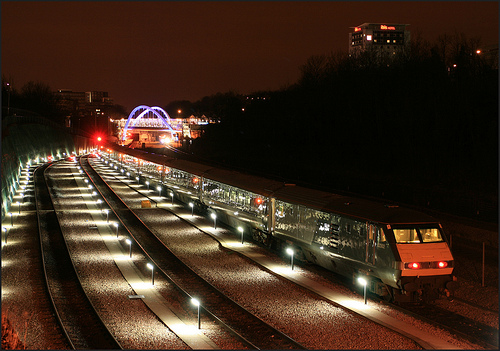How many tracks are shown? There are three tracks visible in the image, illuminated by street lights that cast a warm glow over the railway lines at night-time. 